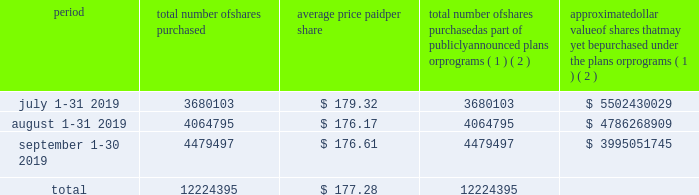Part ii item 5 .
Market for registrant 2019s common equity , related stockholder matters and issuer purchases of equity securities our class a common stock has been listed on the new york stock exchange under the symbol 201cv 201d since march 19 , 2008 .
At november 8 , 2019 , we had 348 stockholders of record of our class a common stock .
The number of beneficial owners is substantially greater than the number of record holders , because a large portion of our class a common stock is held in 201cstreet name 201d by banks and brokers .
There is currently no established public trading market for our class b or c common stock .
There were 1397 and 509 holders of record of our class b and c common stock , respectively , as of november 8 , 2019 .
On october 22 , 2019 , our board of directors declared a quarterly cash dividend of $ 0.30 per share of class a common stock ( determined in the case of class b and c common stock and series b and c preferred stock on an as-converted basis ) payable on december 3 , 2019 , to holders of record as of november 15 , 2019 of our common and preferred stock .
Subject to legally available funds , we expect to continue paying quarterly cash dividends on our outstanding common and preferred stock in the future .
However , the declaration and payment of future dividends is at the sole discretion of our board of directors after taking into account various factors , including our financial condition , settlement indemnifications , operating results , available cash and current and anticipated cash needs .
Issuer purchases of equity securities the table below sets forth our purchases of common stock during the quarter ended september 30 , 2019 .
Period total number of shares purchased average price paid per share total number of shares purchased as part of publicly announced plans or programs ( 1 ) ( 2 ) approximate dollar value of shares that may yet be purchased under the plans or programs ( 1 ) ( 2 ) .
( 1 ) the figures in the table reflect transactions according to the trade dates .
For purposes of our consolidated financial statements included in this form 10-k , the impact of these repurchases is recorded according to the settlement dates .
( 2 ) our board of directors from time to time authorizes the repurchase of shares of our common stock up to a certain monetary limit .
In january 2019 , our board of directors authorized a share repurchase program for $ 8.5 billion .
This authorization has no expiration date .
All share repurchase programs authorized prior to january 2019 have been completed. .
For the quarter ended september 302013 what was the percent of the total number of shares purchased in august? 
Computations: (4064795 / 12224395)
Answer: 0.33252. 